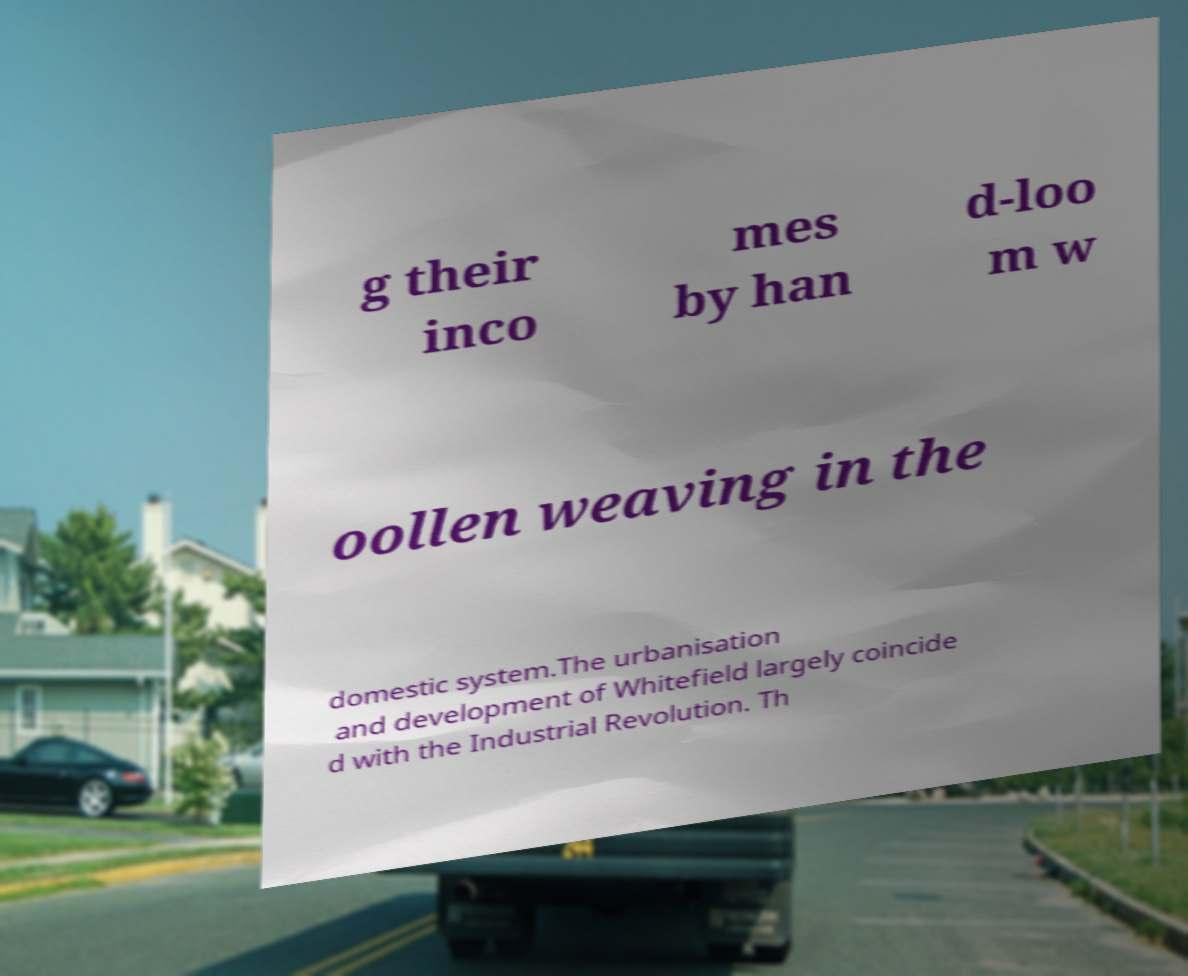For documentation purposes, I need the text within this image transcribed. Could you provide that? g their inco mes by han d-loo m w oollen weaving in the domestic system.The urbanisation and development of Whitefield largely coincide d with the Industrial Revolution. Th 